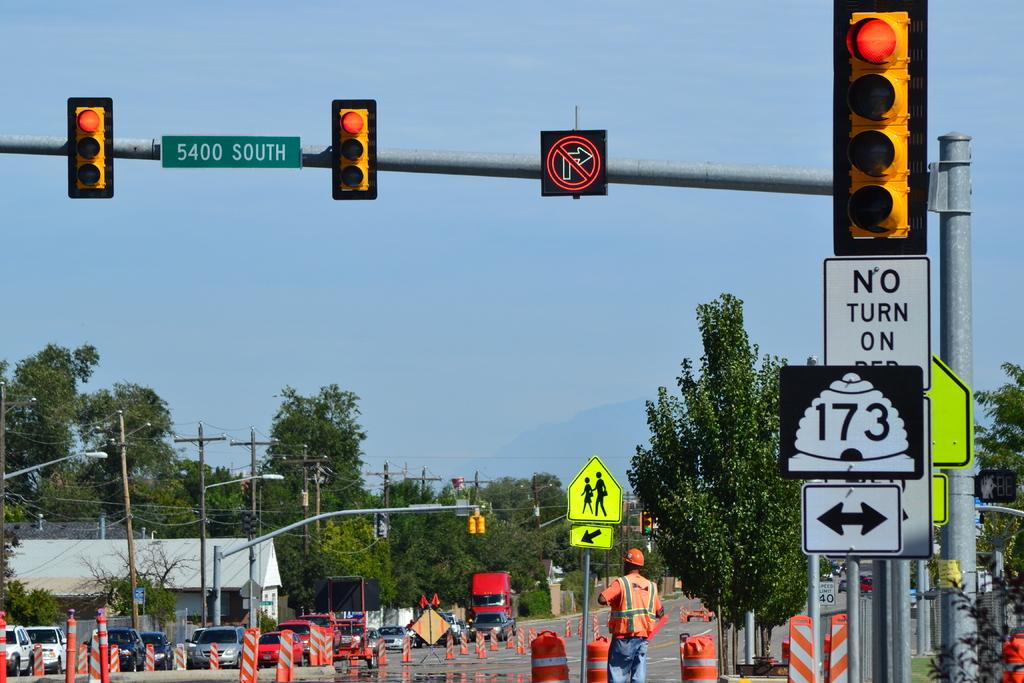<image>
Provide a brief description of the given image. the words no turn on red that is below a light 